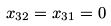Convert formula to latex. <formula><loc_0><loc_0><loc_500><loc_500>x _ { 3 2 } = x _ { 3 1 } = 0</formula> 